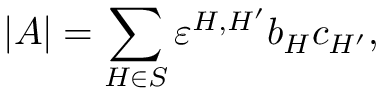Convert formula to latex. <formula><loc_0><loc_0><loc_500><loc_500>| A | = \sum _ { H \in S } \varepsilon ^ { H , H ^ { \prime } } b _ { H } c _ { H ^ { \prime } } ,</formula> 